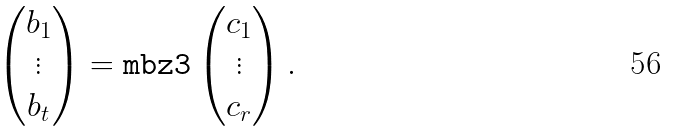<formula> <loc_0><loc_0><loc_500><loc_500>\begin{pmatrix} b _ { 1 } \\ \vdots \\ b _ { t } \end{pmatrix} = \tt m { b z 3 } \begin{pmatrix} c _ { 1 } \\ \vdots \\ c _ { r } \end{pmatrix} .</formula> 